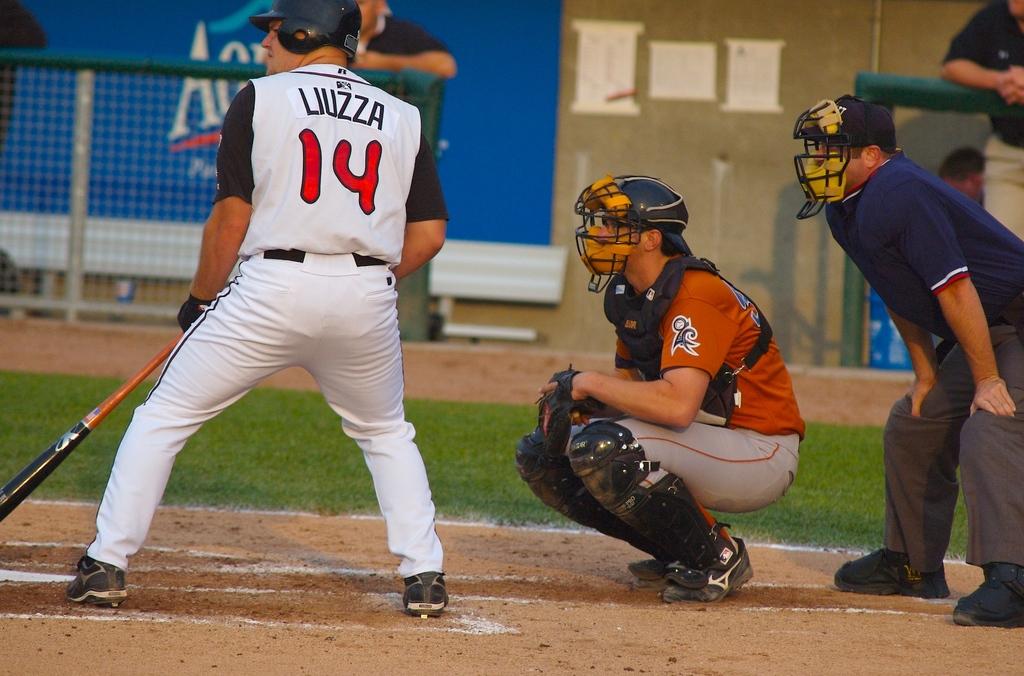What player number is at-bat?
Provide a succinct answer. 14. What is the name of the player batting?
Keep it short and to the point. Liuzza. 